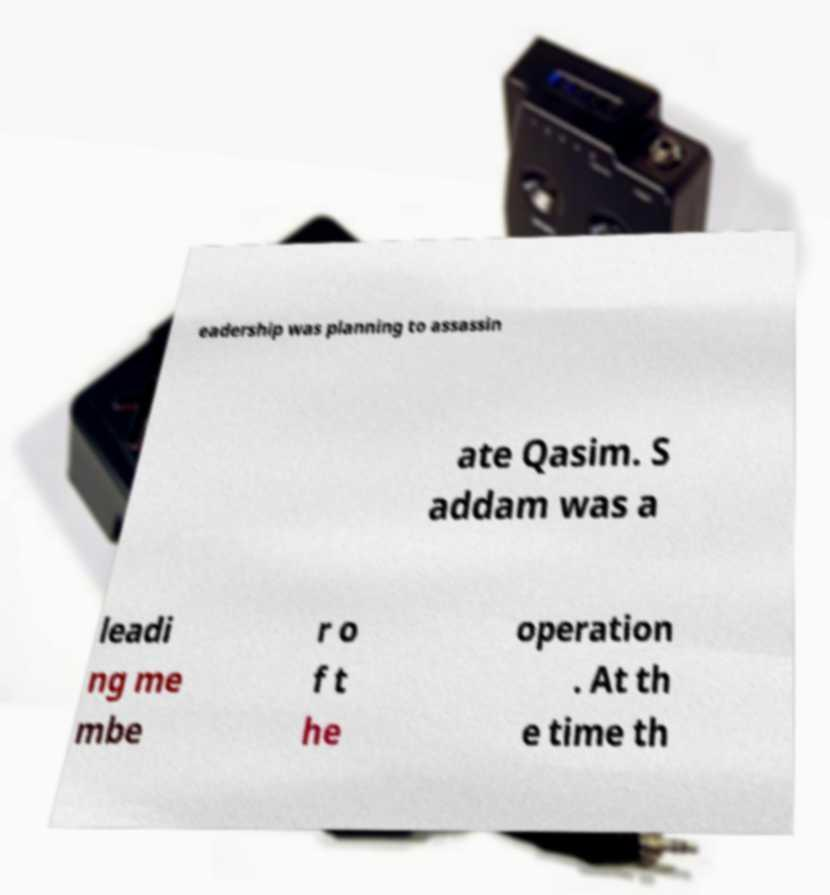What messages or text are displayed in this image? I need them in a readable, typed format. eadership was planning to assassin ate Qasim. S addam was a leadi ng me mbe r o f t he operation . At th e time th 